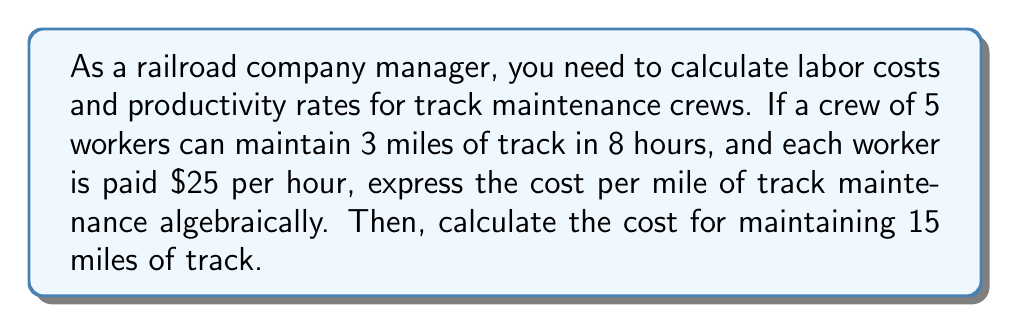Could you help me with this problem? Let's approach this step-by-step:

1) First, let's define our variables:
   $x$ = number of miles maintained
   $y$ = number of hours worked
   $z$ = number of workers

2) We know that 5 workers can maintain 3 miles in 8 hours. We can express this as a rate:
   $$\frac{x}{y} = \frac{3 \text{ miles}}{8 \text{ hours}} = 0.375 \text{ miles/hour}$$

3) This rate is for the entire crew. For a single worker, we divide by the number of workers:
   $$\frac{x}{yz} = \frac{0.375}{5} = 0.075 \text{ miles/hour/worker}$$

4) Now, let's express the cost. Each worker is paid $25/hour, so for $z$ workers working $y$ hours:
   Cost = $25y z$

5) We want cost per mile, so we divide by $x$:
   $$\text{Cost per mile} = \frac{25yz}{x}$$

6) We know that $\frac{x}{yz} = 0.075$, so $x = 0.075yz$

7) Substituting this into our cost per mile equation:
   $$\text{Cost per mile} = \frac{25yz}{0.075yz} = \frac{25}{0.075} = \$333.33 \text{ per mile}$$

8) For 15 miles:
   $$\text{Total cost} = 333.33 \times 15 = \$5,000$$
Answer: $5,000 